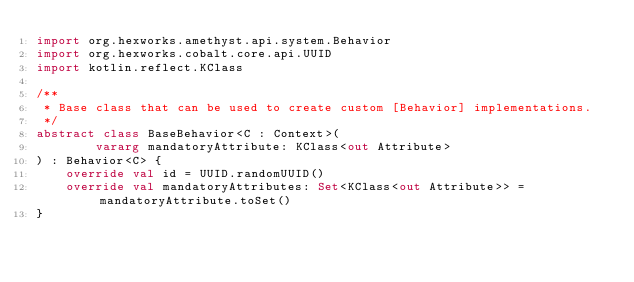<code> <loc_0><loc_0><loc_500><loc_500><_Kotlin_>import org.hexworks.amethyst.api.system.Behavior
import org.hexworks.cobalt.core.api.UUID
import kotlin.reflect.KClass

/**
 * Base class that can be used to create custom [Behavior] implementations.
 */
abstract class BaseBehavior<C : Context>(
        vararg mandatoryAttribute: KClass<out Attribute>
) : Behavior<C> {
    override val id = UUID.randomUUID()
    override val mandatoryAttributes: Set<KClass<out Attribute>> = mandatoryAttribute.toSet()
}
</code> 